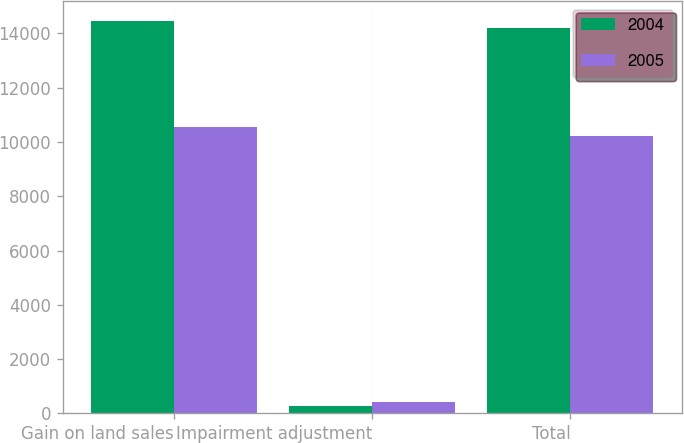<chart> <loc_0><loc_0><loc_500><loc_500><stacked_bar_chart><ecel><fcel>Gain on land sales<fcel>Impairment adjustment<fcel>Total<nl><fcel>2004<fcel>14459<fcel>258<fcel>14201<nl><fcel>2005<fcel>10543<fcel>424<fcel>10202<nl></chart> 